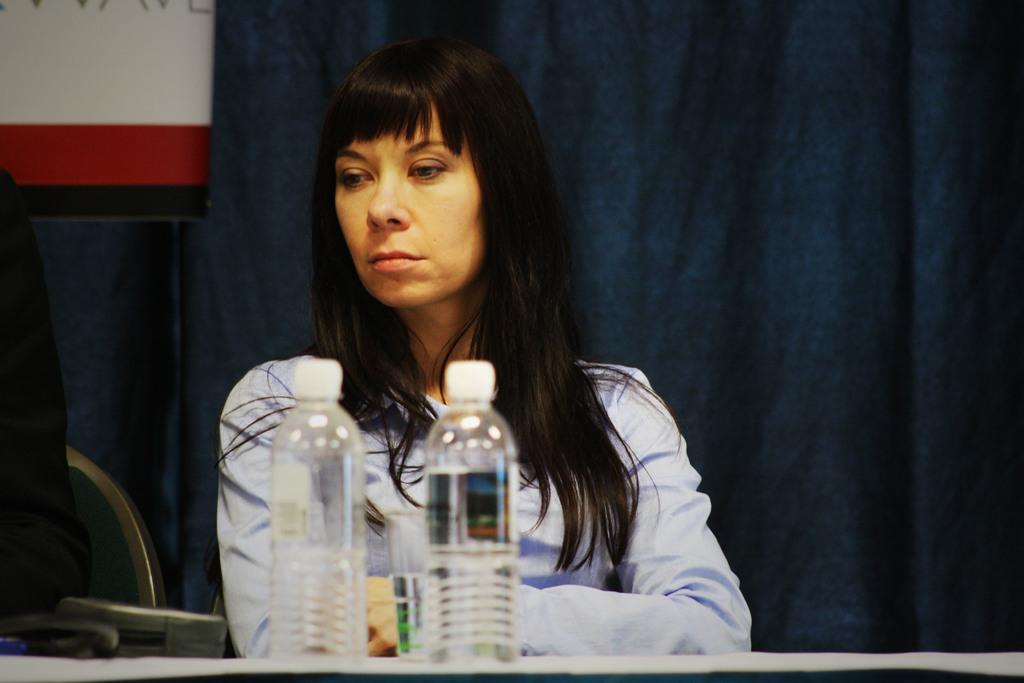Who is present in the image? There is a woman in the image. What is the woman doing in the image? The woman is sitting on a chair in the image. Where is the woman located in the image? The woman is at a table in the image. What items can be seen on the table? There are water bottles and glasses on the table in the image. What can be seen in the background of the image? There is a curtain and a wall in the background of the image. How does the woman guide the fog in the image? There is no fog present in the image, and therefore no guiding can be observed. 